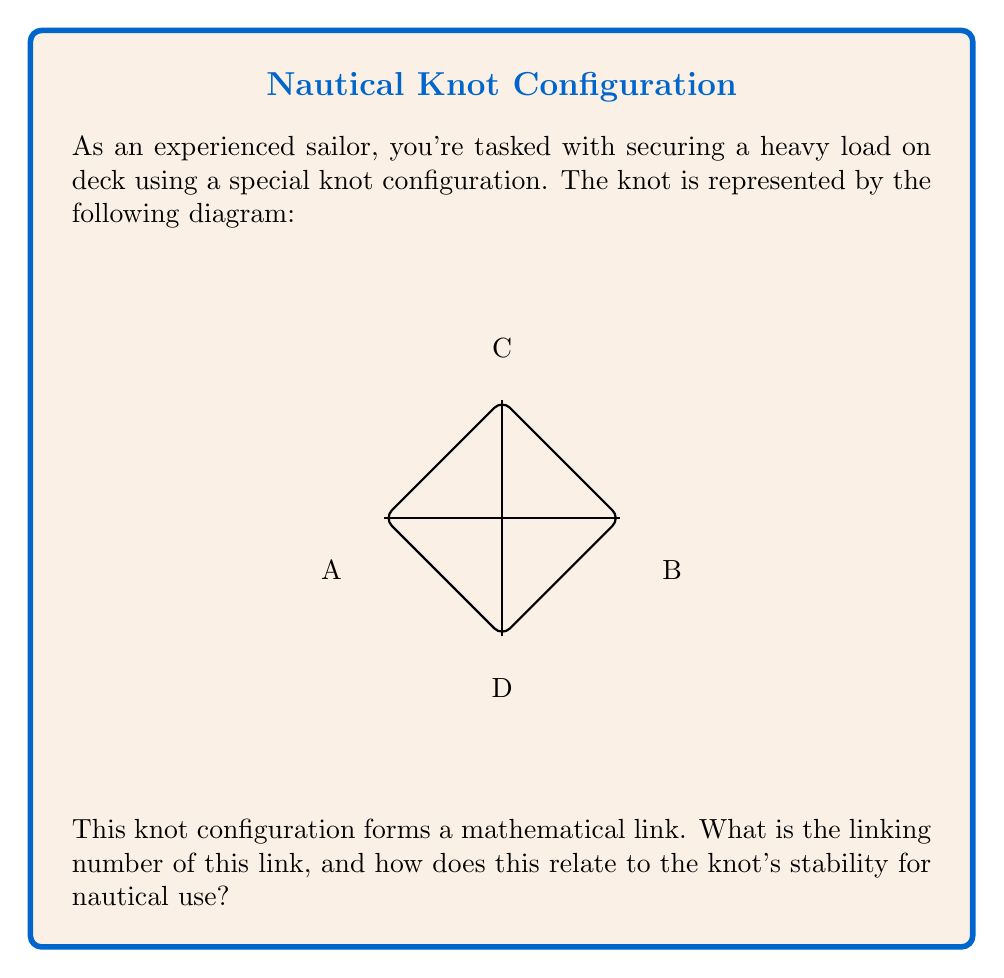Could you help me with this problem? To solve this problem, we'll follow these steps:

1) First, let's understand what a linking number is:
   The linking number is a topological invariant that measures how many times one curve winds around another in three-dimensional space.

2) To calculate the linking number, we need to:
   a) Choose an orientation for each component of the link
   b) Count the number of crossings, assigning +1 or -1 based on the orientation

3) In this diagram, we have two components:
   - Component 1: The outer loop ACBDA
   - Component 2: The vertical line CD

4) Let's assign clockwise orientation to Component 1 and upward orientation to Component 2.

5) Now, we count the crossings:
   - At point C: +1 (Component 2 crosses over Component 1 in agreement with orientations)
   - At point D: -1 (Component 2 crosses under Component 1, against the orientations)

6) The linking number is half the sum of these crossing numbers:
   $$ \text{Linking Number} = \frac{1}{2}(+1 + (-1)) = 0 $$

7) The linking number of 0 indicates that the components can be separated without cutting either strand. In nautical terms, this means:
   - The knot is less stable and more likely to come undone under stress
   - It allows for quick release if needed, which can be advantageous in certain situations

8) For securing heavy loads, a non-zero linking number would generally be preferred as it indicates a more interlocked and stable configuration.
Answer: Linking number: 0. Implications: Less stable, easier to undo, quick-release capable. 